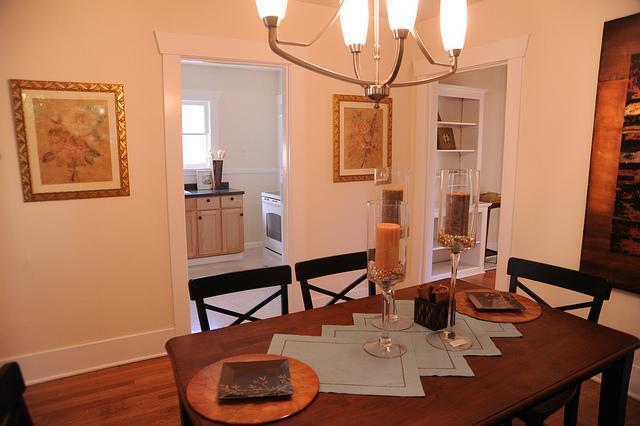How many wine glasses can you see?
Give a very brief answer. 2. How many chairs can you see?
Give a very brief answer. 3. 